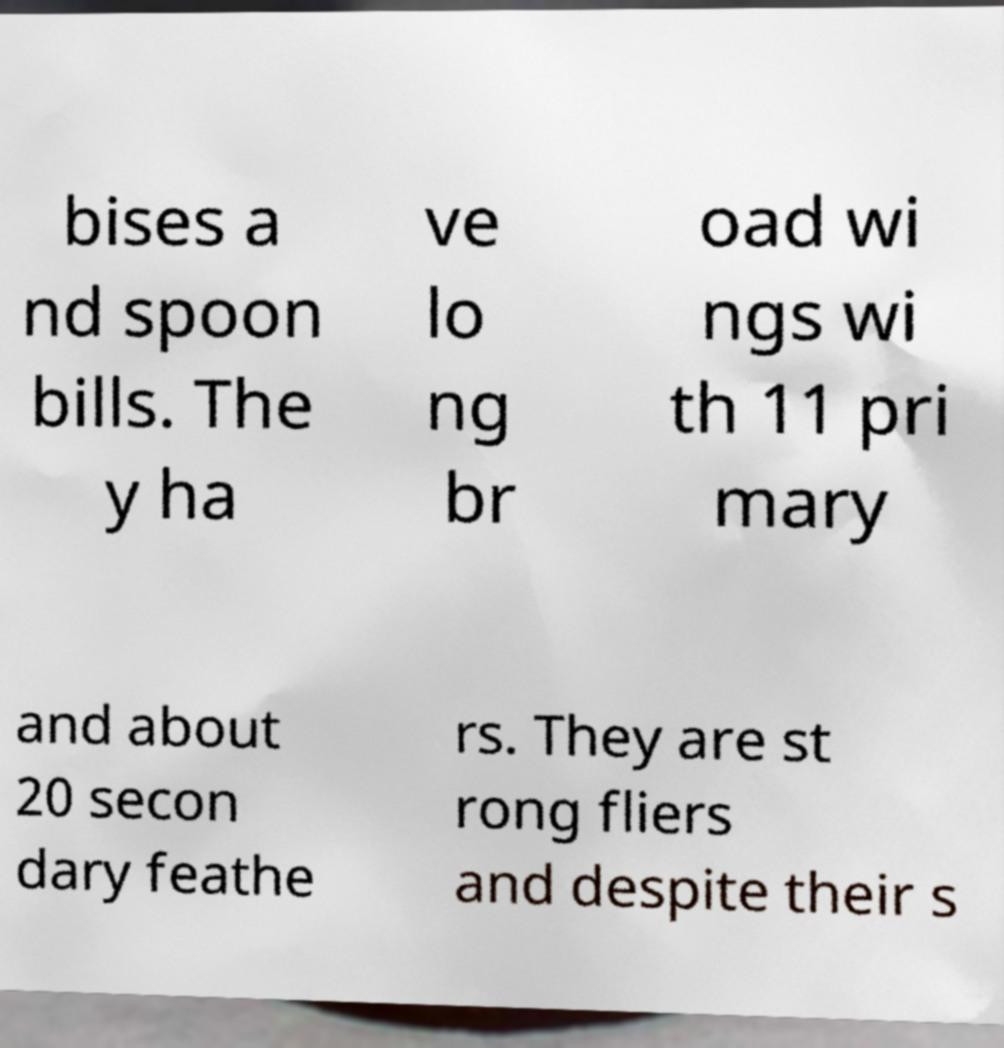Can you read and provide the text displayed in the image?This photo seems to have some interesting text. Can you extract and type it out for me? bises a nd spoon bills. The y ha ve lo ng br oad wi ngs wi th 11 pri mary and about 20 secon dary feathe rs. They are st rong fliers and despite their s 